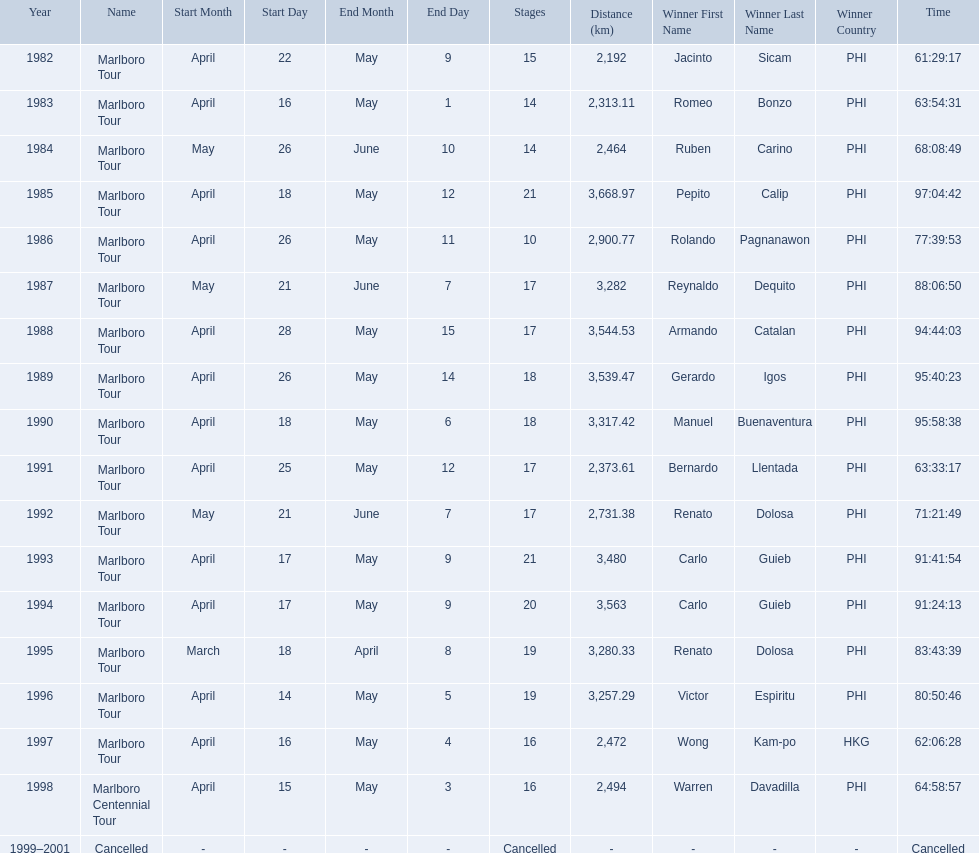Which year did warren davdilla (w.d.) appear? 1998. What tour did w.d. complete? Marlboro Centennial Tour. What is the time recorded in the same row as w.d.? 64:58:57. 